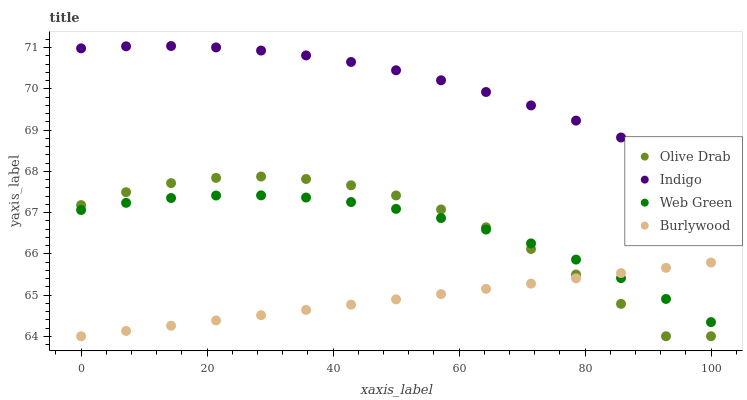Does Burlywood have the minimum area under the curve?
Answer yes or no. Yes. Does Indigo have the maximum area under the curve?
Answer yes or no. Yes. Does Web Green have the minimum area under the curve?
Answer yes or no. No. Does Web Green have the maximum area under the curve?
Answer yes or no. No. Is Burlywood the smoothest?
Answer yes or no. Yes. Is Olive Drab the roughest?
Answer yes or no. Yes. Is Indigo the smoothest?
Answer yes or no. No. Is Indigo the roughest?
Answer yes or no. No. Does Burlywood have the lowest value?
Answer yes or no. Yes. Does Web Green have the lowest value?
Answer yes or no. No. Does Indigo have the highest value?
Answer yes or no. Yes. Does Web Green have the highest value?
Answer yes or no. No. Is Olive Drab less than Indigo?
Answer yes or no. Yes. Is Indigo greater than Web Green?
Answer yes or no. Yes. Does Burlywood intersect Web Green?
Answer yes or no. Yes. Is Burlywood less than Web Green?
Answer yes or no. No. Is Burlywood greater than Web Green?
Answer yes or no. No. Does Olive Drab intersect Indigo?
Answer yes or no. No. 